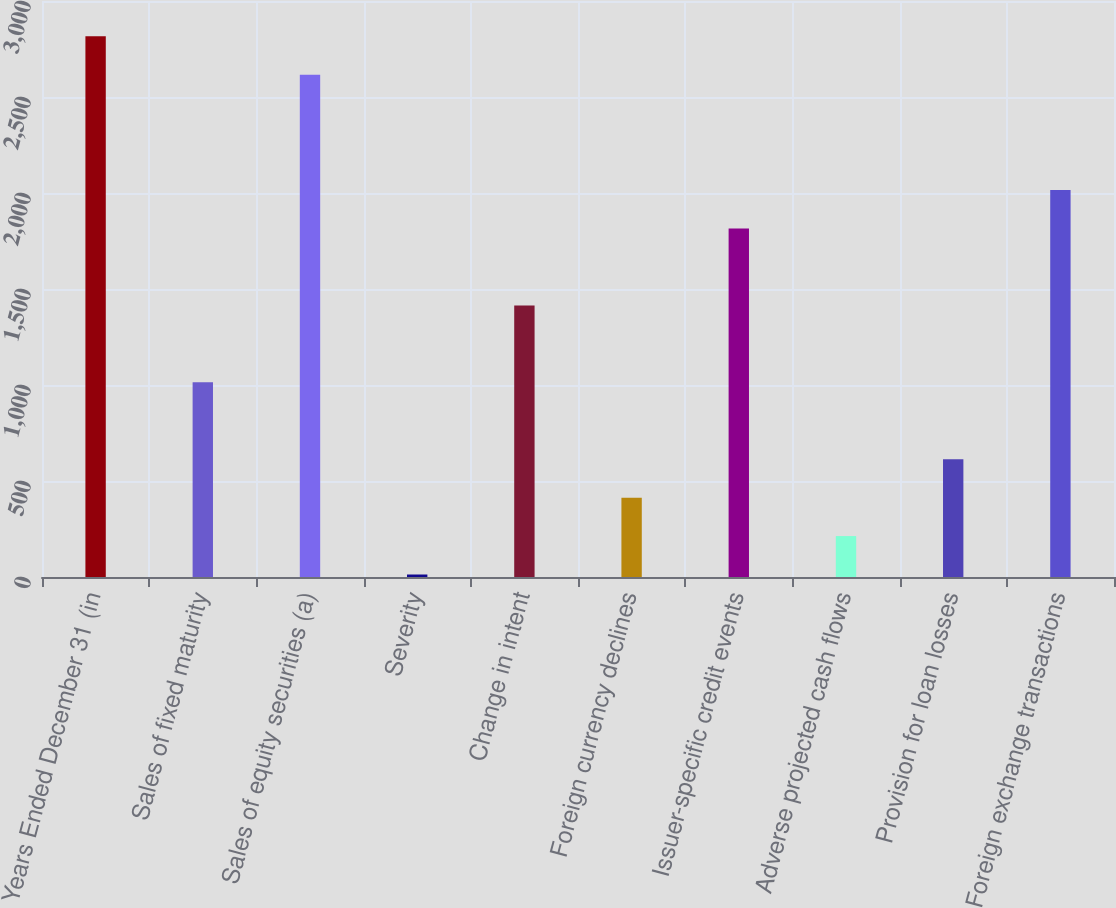Convert chart to OTSL. <chart><loc_0><loc_0><loc_500><loc_500><bar_chart><fcel>Years Ended December 31 (in<fcel>Sales of fixed maturity<fcel>Sales of equity securities (a)<fcel>Severity<fcel>Change in intent<fcel>Foreign currency declines<fcel>Issuer-specific credit events<fcel>Adverse projected cash flows<fcel>Provision for loan losses<fcel>Foreign exchange transactions<nl><fcel>2815.8<fcel>1014<fcel>2615.6<fcel>13<fcel>1414.4<fcel>413.4<fcel>1814.8<fcel>213.2<fcel>613.6<fcel>2015<nl></chart> 